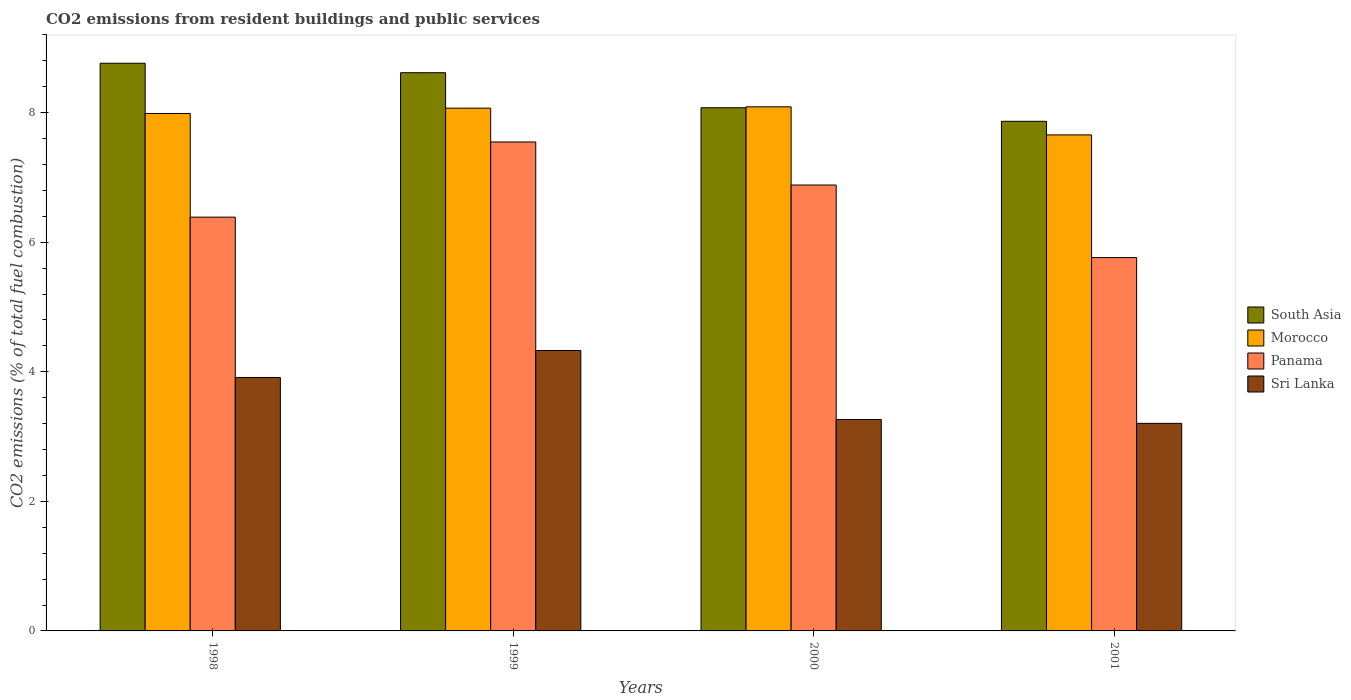How many groups of bars are there?
Make the answer very short. 4. Are the number of bars on each tick of the X-axis equal?
Give a very brief answer. Yes. How many bars are there on the 1st tick from the left?
Ensure brevity in your answer.  4. What is the total CO2 emitted in Sri Lanka in 2000?
Provide a short and direct response. 3.26. Across all years, what is the maximum total CO2 emitted in Morocco?
Provide a succinct answer. 8.09. Across all years, what is the minimum total CO2 emitted in Sri Lanka?
Your response must be concise. 3.2. In which year was the total CO2 emitted in Sri Lanka maximum?
Ensure brevity in your answer.  1999. In which year was the total CO2 emitted in Morocco minimum?
Offer a terse response. 2001. What is the total total CO2 emitted in Morocco in the graph?
Keep it short and to the point. 31.8. What is the difference between the total CO2 emitted in Panama in 1998 and that in 2000?
Provide a succinct answer. -0.5. What is the difference between the total CO2 emitted in Morocco in 2000 and the total CO2 emitted in South Asia in 2001?
Your answer should be very brief. 0.22. What is the average total CO2 emitted in South Asia per year?
Your response must be concise. 8.33. In the year 2001, what is the difference between the total CO2 emitted in Morocco and total CO2 emitted in Panama?
Keep it short and to the point. 1.89. In how many years, is the total CO2 emitted in Morocco greater than 6.8?
Provide a succinct answer. 4. What is the ratio of the total CO2 emitted in Panama in 1999 to that in 2001?
Your answer should be compact. 1.31. Is the difference between the total CO2 emitted in Morocco in 1999 and 2000 greater than the difference between the total CO2 emitted in Panama in 1999 and 2000?
Ensure brevity in your answer.  No. What is the difference between the highest and the second highest total CO2 emitted in Sri Lanka?
Ensure brevity in your answer.  0.42. What is the difference between the highest and the lowest total CO2 emitted in Morocco?
Your answer should be compact. 0.43. Is the sum of the total CO2 emitted in Sri Lanka in 2000 and 2001 greater than the maximum total CO2 emitted in South Asia across all years?
Ensure brevity in your answer.  No. Is it the case that in every year, the sum of the total CO2 emitted in Sri Lanka and total CO2 emitted in Panama is greater than the sum of total CO2 emitted in South Asia and total CO2 emitted in Morocco?
Your response must be concise. No. What does the 3rd bar from the left in 1999 represents?
Keep it short and to the point. Panama. What does the 3rd bar from the right in 1998 represents?
Ensure brevity in your answer.  Morocco. How many bars are there?
Make the answer very short. 16. Are all the bars in the graph horizontal?
Provide a succinct answer. No. How many years are there in the graph?
Provide a short and direct response. 4. What is the title of the graph?
Ensure brevity in your answer.  CO2 emissions from resident buildings and public services. What is the label or title of the X-axis?
Provide a short and direct response. Years. What is the label or title of the Y-axis?
Offer a terse response. CO2 emissions (% of total fuel combustion). What is the CO2 emissions (% of total fuel combustion) of South Asia in 1998?
Give a very brief answer. 8.76. What is the CO2 emissions (% of total fuel combustion) in Morocco in 1998?
Your answer should be very brief. 7.99. What is the CO2 emissions (% of total fuel combustion) in Panama in 1998?
Your response must be concise. 6.39. What is the CO2 emissions (% of total fuel combustion) of Sri Lanka in 1998?
Your response must be concise. 3.91. What is the CO2 emissions (% of total fuel combustion) in South Asia in 1999?
Provide a short and direct response. 8.62. What is the CO2 emissions (% of total fuel combustion) in Morocco in 1999?
Provide a short and direct response. 8.07. What is the CO2 emissions (% of total fuel combustion) in Panama in 1999?
Make the answer very short. 7.55. What is the CO2 emissions (% of total fuel combustion) in Sri Lanka in 1999?
Your response must be concise. 4.33. What is the CO2 emissions (% of total fuel combustion) of South Asia in 2000?
Your answer should be very brief. 8.08. What is the CO2 emissions (% of total fuel combustion) in Morocco in 2000?
Make the answer very short. 8.09. What is the CO2 emissions (% of total fuel combustion) in Panama in 2000?
Your response must be concise. 6.88. What is the CO2 emissions (% of total fuel combustion) of Sri Lanka in 2000?
Ensure brevity in your answer.  3.26. What is the CO2 emissions (% of total fuel combustion) in South Asia in 2001?
Your response must be concise. 7.87. What is the CO2 emissions (% of total fuel combustion) of Morocco in 2001?
Ensure brevity in your answer.  7.66. What is the CO2 emissions (% of total fuel combustion) in Panama in 2001?
Provide a succinct answer. 5.76. What is the CO2 emissions (% of total fuel combustion) of Sri Lanka in 2001?
Give a very brief answer. 3.2. Across all years, what is the maximum CO2 emissions (% of total fuel combustion) in South Asia?
Offer a terse response. 8.76. Across all years, what is the maximum CO2 emissions (% of total fuel combustion) in Morocco?
Your answer should be compact. 8.09. Across all years, what is the maximum CO2 emissions (% of total fuel combustion) in Panama?
Your answer should be very brief. 7.55. Across all years, what is the maximum CO2 emissions (% of total fuel combustion) in Sri Lanka?
Offer a very short reply. 4.33. Across all years, what is the minimum CO2 emissions (% of total fuel combustion) in South Asia?
Make the answer very short. 7.87. Across all years, what is the minimum CO2 emissions (% of total fuel combustion) of Morocco?
Offer a very short reply. 7.66. Across all years, what is the minimum CO2 emissions (% of total fuel combustion) of Panama?
Your response must be concise. 5.76. Across all years, what is the minimum CO2 emissions (% of total fuel combustion) of Sri Lanka?
Give a very brief answer. 3.2. What is the total CO2 emissions (% of total fuel combustion) of South Asia in the graph?
Your answer should be very brief. 33.32. What is the total CO2 emissions (% of total fuel combustion) of Morocco in the graph?
Offer a very short reply. 31.8. What is the total CO2 emissions (% of total fuel combustion) in Panama in the graph?
Provide a short and direct response. 26.58. What is the total CO2 emissions (% of total fuel combustion) of Sri Lanka in the graph?
Your response must be concise. 14.71. What is the difference between the CO2 emissions (% of total fuel combustion) of South Asia in 1998 and that in 1999?
Provide a succinct answer. 0.15. What is the difference between the CO2 emissions (% of total fuel combustion) of Morocco in 1998 and that in 1999?
Your answer should be compact. -0.08. What is the difference between the CO2 emissions (% of total fuel combustion) in Panama in 1998 and that in 1999?
Offer a terse response. -1.16. What is the difference between the CO2 emissions (% of total fuel combustion) in Sri Lanka in 1998 and that in 1999?
Offer a very short reply. -0.42. What is the difference between the CO2 emissions (% of total fuel combustion) in South Asia in 1998 and that in 2000?
Offer a very short reply. 0.69. What is the difference between the CO2 emissions (% of total fuel combustion) in Morocco in 1998 and that in 2000?
Your response must be concise. -0.1. What is the difference between the CO2 emissions (% of total fuel combustion) in Panama in 1998 and that in 2000?
Provide a succinct answer. -0.5. What is the difference between the CO2 emissions (% of total fuel combustion) of Sri Lanka in 1998 and that in 2000?
Offer a terse response. 0.65. What is the difference between the CO2 emissions (% of total fuel combustion) of South Asia in 1998 and that in 2001?
Offer a terse response. 0.9. What is the difference between the CO2 emissions (% of total fuel combustion) of Morocco in 1998 and that in 2001?
Your response must be concise. 0.33. What is the difference between the CO2 emissions (% of total fuel combustion) of Panama in 1998 and that in 2001?
Offer a very short reply. 0.62. What is the difference between the CO2 emissions (% of total fuel combustion) of Sri Lanka in 1998 and that in 2001?
Ensure brevity in your answer.  0.71. What is the difference between the CO2 emissions (% of total fuel combustion) of South Asia in 1999 and that in 2000?
Your answer should be compact. 0.54. What is the difference between the CO2 emissions (% of total fuel combustion) of Morocco in 1999 and that in 2000?
Make the answer very short. -0.02. What is the difference between the CO2 emissions (% of total fuel combustion) of Panama in 1999 and that in 2000?
Ensure brevity in your answer.  0.66. What is the difference between the CO2 emissions (% of total fuel combustion) in Sri Lanka in 1999 and that in 2000?
Provide a succinct answer. 1.07. What is the difference between the CO2 emissions (% of total fuel combustion) of South Asia in 1999 and that in 2001?
Keep it short and to the point. 0.75. What is the difference between the CO2 emissions (% of total fuel combustion) in Morocco in 1999 and that in 2001?
Make the answer very short. 0.41. What is the difference between the CO2 emissions (% of total fuel combustion) of Panama in 1999 and that in 2001?
Offer a very short reply. 1.78. What is the difference between the CO2 emissions (% of total fuel combustion) of Sri Lanka in 1999 and that in 2001?
Your answer should be compact. 1.12. What is the difference between the CO2 emissions (% of total fuel combustion) in South Asia in 2000 and that in 2001?
Keep it short and to the point. 0.21. What is the difference between the CO2 emissions (% of total fuel combustion) in Morocco in 2000 and that in 2001?
Your response must be concise. 0.43. What is the difference between the CO2 emissions (% of total fuel combustion) in Panama in 2000 and that in 2001?
Give a very brief answer. 1.12. What is the difference between the CO2 emissions (% of total fuel combustion) of Sri Lanka in 2000 and that in 2001?
Give a very brief answer. 0.06. What is the difference between the CO2 emissions (% of total fuel combustion) of South Asia in 1998 and the CO2 emissions (% of total fuel combustion) of Morocco in 1999?
Offer a very short reply. 0.69. What is the difference between the CO2 emissions (% of total fuel combustion) of South Asia in 1998 and the CO2 emissions (% of total fuel combustion) of Panama in 1999?
Give a very brief answer. 1.21. What is the difference between the CO2 emissions (% of total fuel combustion) of South Asia in 1998 and the CO2 emissions (% of total fuel combustion) of Sri Lanka in 1999?
Give a very brief answer. 4.43. What is the difference between the CO2 emissions (% of total fuel combustion) in Morocco in 1998 and the CO2 emissions (% of total fuel combustion) in Panama in 1999?
Provide a succinct answer. 0.44. What is the difference between the CO2 emissions (% of total fuel combustion) of Morocco in 1998 and the CO2 emissions (% of total fuel combustion) of Sri Lanka in 1999?
Your response must be concise. 3.66. What is the difference between the CO2 emissions (% of total fuel combustion) of Panama in 1998 and the CO2 emissions (% of total fuel combustion) of Sri Lanka in 1999?
Offer a terse response. 2.06. What is the difference between the CO2 emissions (% of total fuel combustion) in South Asia in 1998 and the CO2 emissions (% of total fuel combustion) in Morocco in 2000?
Your response must be concise. 0.67. What is the difference between the CO2 emissions (% of total fuel combustion) of South Asia in 1998 and the CO2 emissions (% of total fuel combustion) of Panama in 2000?
Make the answer very short. 1.88. What is the difference between the CO2 emissions (% of total fuel combustion) in South Asia in 1998 and the CO2 emissions (% of total fuel combustion) in Sri Lanka in 2000?
Offer a very short reply. 5.5. What is the difference between the CO2 emissions (% of total fuel combustion) in Morocco in 1998 and the CO2 emissions (% of total fuel combustion) in Panama in 2000?
Offer a very short reply. 1.1. What is the difference between the CO2 emissions (% of total fuel combustion) in Morocco in 1998 and the CO2 emissions (% of total fuel combustion) in Sri Lanka in 2000?
Give a very brief answer. 4.72. What is the difference between the CO2 emissions (% of total fuel combustion) of Panama in 1998 and the CO2 emissions (% of total fuel combustion) of Sri Lanka in 2000?
Offer a terse response. 3.12. What is the difference between the CO2 emissions (% of total fuel combustion) in South Asia in 1998 and the CO2 emissions (% of total fuel combustion) in Morocco in 2001?
Make the answer very short. 1.11. What is the difference between the CO2 emissions (% of total fuel combustion) in South Asia in 1998 and the CO2 emissions (% of total fuel combustion) in Panama in 2001?
Provide a short and direct response. 3. What is the difference between the CO2 emissions (% of total fuel combustion) of South Asia in 1998 and the CO2 emissions (% of total fuel combustion) of Sri Lanka in 2001?
Offer a very short reply. 5.56. What is the difference between the CO2 emissions (% of total fuel combustion) in Morocco in 1998 and the CO2 emissions (% of total fuel combustion) in Panama in 2001?
Keep it short and to the point. 2.22. What is the difference between the CO2 emissions (% of total fuel combustion) in Morocco in 1998 and the CO2 emissions (% of total fuel combustion) in Sri Lanka in 2001?
Make the answer very short. 4.78. What is the difference between the CO2 emissions (% of total fuel combustion) in Panama in 1998 and the CO2 emissions (% of total fuel combustion) in Sri Lanka in 2001?
Provide a succinct answer. 3.18. What is the difference between the CO2 emissions (% of total fuel combustion) in South Asia in 1999 and the CO2 emissions (% of total fuel combustion) in Morocco in 2000?
Your answer should be compact. 0.53. What is the difference between the CO2 emissions (% of total fuel combustion) in South Asia in 1999 and the CO2 emissions (% of total fuel combustion) in Panama in 2000?
Provide a short and direct response. 1.73. What is the difference between the CO2 emissions (% of total fuel combustion) of South Asia in 1999 and the CO2 emissions (% of total fuel combustion) of Sri Lanka in 2000?
Give a very brief answer. 5.35. What is the difference between the CO2 emissions (% of total fuel combustion) of Morocco in 1999 and the CO2 emissions (% of total fuel combustion) of Panama in 2000?
Make the answer very short. 1.19. What is the difference between the CO2 emissions (% of total fuel combustion) in Morocco in 1999 and the CO2 emissions (% of total fuel combustion) in Sri Lanka in 2000?
Provide a short and direct response. 4.81. What is the difference between the CO2 emissions (% of total fuel combustion) of Panama in 1999 and the CO2 emissions (% of total fuel combustion) of Sri Lanka in 2000?
Provide a short and direct response. 4.28. What is the difference between the CO2 emissions (% of total fuel combustion) in South Asia in 1999 and the CO2 emissions (% of total fuel combustion) in Morocco in 2001?
Keep it short and to the point. 0.96. What is the difference between the CO2 emissions (% of total fuel combustion) of South Asia in 1999 and the CO2 emissions (% of total fuel combustion) of Panama in 2001?
Provide a short and direct response. 2.85. What is the difference between the CO2 emissions (% of total fuel combustion) of South Asia in 1999 and the CO2 emissions (% of total fuel combustion) of Sri Lanka in 2001?
Keep it short and to the point. 5.41. What is the difference between the CO2 emissions (% of total fuel combustion) in Morocco in 1999 and the CO2 emissions (% of total fuel combustion) in Panama in 2001?
Ensure brevity in your answer.  2.31. What is the difference between the CO2 emissions (% of total fuel combustion) in Morocco in 1999 and the CO2 emissions (% of total fuel combustion) in Sri Lanka in 2001?
Your response must be concise. 4.87. What is the difference between the CO2 emissions (% of total fuel combustion) in Panama in 1999 and the CO2 emissions (% of total fuel combustion) in Sri Lanka in 2001?
Ensure brevity in your answer.  4.34. What is the difference between the CO2 emissions (% of total fuel combustion) in South Asia in 2000 and the CO2 emissions (% of total fuel combustion) in Morocco in 2001?
Your response must be concise. 0.42. What is the difference between the CO2 emissions (% of total fuel combustion) of South Asia in 2000 and the CO2 emissions (% of total fuel combustion) of Panama in 2001?
Keep it short and to the point. 2.31. What is the difference between the CO2 emissions (% of total fuel combustion) in South Asia in 2000 and the CO2 emissions (% of total fuel combustion) in Sri Lanka in 2001?
Offer a very short reply. 4.87. What is the difference between the CO2 emissions (% of total fuel combustion) of Morocco in 2000 and the CO2 emissions (% of total fuel combustion) of Panama in 2001?
Your response must be concise. 2.33. What is the difference between the CO2 emissions (% of total fuel combustion) in Morocco in 2000 and the CO2 emissions (% of total fuel combustion) in Sri Lanka in 2001?
Offer a very short reply. 4.89. What is the difference between the CO2 emissions (% of total fuel combustion) in Panama in 2000 and the CO2 emissions (% of total fuel combustion) in Sri Lanka in 2001?
Your answer should be very brief. 3.68. What is the average CO2 emissions (% of total fuel combustion) in South Asia per year?
Ensure brevity in your answer.  8.33. What is the average CO2 emissions (% of total fuel combustion) of Morocco per year?
Your answer should be compact. 7.95. What is the average CO2 emissions (% of total fuel combustion) in Panama per year?
Your response must be concise. 6.64. What is the average CO2 emissions (% of total fuel combustion) of Sri Lanka per year?
Your response must be concise. 3.68. In the year 1998, what is the difference between the CO2 emissions (% of total fuel combustion) in South Asia and CO2 emissions (% of total fuel combustion) in Morocco?
Your answer should be very brief. 0.78. In the year 1998, what is the difference between the CO2 emissions (% of total fuel combustion) of South Asia and CO2 emissions (% of total fuel combustion) of Panama?
Make the answer very short. 2.38. In the year 1998, what is the difference between the CO2 emissions (% of total fuel combustion) in South Asia and CO2 emissions (% of total fuel combustion) in Sri Lanka?
Your answer should be compact. 4.85. In the year 1998, what is the difference between the CO2 emissions (% of total fuel combustion) of Morocco and CO2 emissions (% of total fuel combustion) of Sri Lanka?
Ensure brevity in your answer.  4.07. In the year 1998, what is the difference between the CO2 emissions (% of total fuel combustion) in Panama and CO2 emissions (% of total fuel combustion) in Sri Lanka?
Make the answer very short. 2.47. In the year 1999, what is the difference between the CO2 emissions (% of total fuel combustion) in South Asia and CO2 emissions (% of total fuel combustion) in Morocco?
Provide a short and direct response. 0.55. In the year 1999, what is the difference between the CO2 emissions (% of total fuel combustion) in South Asia and CO2 emissions (% of total fuel combustion) in Panama?
Provide a short and direct response. 1.07. In the year 1999, what is the difference between the CO2 emissions (% of total fuel combustion) in South Asia and CO2 emissions (% of total fuel combustion) in Sri Lanka?
Offer a terse response. 4.29. In the year 1999, what is the difference between the CO2 emissions (% of total fuel combustion) of Morocco and CO2 emissions (% of total fuel combustion) of Panama?
Keep it short and to the point. 0.52. In the year 1999, what is the difference between the CO2 emissions (% of total fuel combustion) in Morocco and CO2 emissions (% of total fuel combustion) in Sri Lanka?
Provide a short and direct response. 3.74. In the year 1999, what is the difference between the CO2 emissions (% of total fuel combustion) in Panama and CO2 emissions (% of total fuel combustion) in Sri Lanka?
Your answer should be compact. 3.22. In the year 2000, what is the difference between the CO2 emissions (% of total fuel combustion) in South Asia and CO2 emissions (% of total fuel combustion) in Morocco?
Provide a short and direct response. -0.01. In the year 2000, what is the difference between the CO2 emissions (% of total fuel combustion) of South Asia and CO2 emissions (% of total fuel combustion) of Panama?
Keep it short and to the point. 1.19. In the year 2000, what is the difference between the CO2 emissions (% of total fuel combustion) in South Asia and CO2 emissions (% of total fuel combustion) in Sri Lanka?
Your answer should be very brief. 4.81. In the year 2000, what is the difference between the CO2 emissions (% of total fuel combustion) of Morocco and CO2 emissions (% of total fuel combustion) of Panama?
Make the answer very short. 1.21. In the year 2000, what is the difference between the CO2 emissions (% of total fuel combustion) in Morocco and CO2 emissions (% of total fuel combustion) in Sri Lanka?
Give a very brief answer. 4.83. In the year 2000, what is the difference between the CO2 emissions (% of total fuel combustion) in Panama and CO2 emissions (% of total fuel combustion) in Sri Lanka?
Give a very brief answer. 3.62. In the year 2001, what is the difference between the CO2 emissions (% of total fuel combustion) in South Asia and CO2 emissions (% of total fuel combustion) in Morocco?
Provide a succinct answer. 0.21. In the year 2001, what is the difference between the CO2 emissions (% of total fuel combustion) in South Asia and CO2 emissions (% of total fuel combustion) in Panama?
Keep it short and to the point. 2.1. In the year 2001, what is the difference between the CO2 emissions (% of total fuel combustion) of South Asia and CO2 emissions (% of total fuel combustion) of Sri Lanka?
Keep it short and to the point. 4.66. In the year 2001, what is the difference between the CO2 emissions (% of total fuel combustion) in Morocco and CO2 emissions (% of total fuel combustion) in Panama?
Provide a short and direct response. 1.89. In the year 2001, what is the difference between the CO2 emissions (% of total fuel combustion) in Morocco and CO2 emissions (% of total fuel combustion) in Sri Lanka?
Give a very brief answer. 4.45. In the year 2001, what is the difference between the CO2 emissions (% of total fuel combustion) of Panama and CO2 emissions (% of total fuel combustion) of Sri Lanka?
Make the answer very short. 2.56. What is the ratio of the CO2 emissions (% of total fuel combustion) in South Asia in 1998 to that in 1999?
Provide a short and direct response. 1.02. What is the ratio of the CO2 emissions (% of total fuel combustion) in Panama in 1998 to that in 1999?
Ensure brevity in your answer.  0.85. What is the ratio of the CO2 emissions (% of total fuel combustion) of Sri Lanka in 1998 to that in 1999?
Provide a succinct answer. 0.9. What is the ratio of the CO2 emissions (% of total fuel combustion) of South Asia in 1998 to that in 2000?
Keep it short and to the point. 1.08. What is the ratio of the CO2 emissions (% of total fuel combustion) in Morocco in 1998 to that in 2000?
Ensure brevity in your answer.  0.99. What is the ratio of the CO2 emissions (% of total fuel combustion) of Panama in 1998 to that in 2000?
Your response must be concise. 0.93. What is the ratio of the CO2 emissions (% of total fuel combustion) of Sri Lanka in 1998 to that in 2000?
Give a very brief answer. 1.2. What is the ratio of the CO2 emissions (% of total fuel combustion) of South Asia in 1998 to that in 2001?
Your answer should be compact. 1.11. What is the ratio of the CO2 emissions (% of total fuel combustion) of Morocco in 1998 to that in 2001?
Provide a succinct answer. 1.04. What is the ratio of the CO2 emissions (% of total fuel combustion) of Panama in 1998 to that in 2001?
Your answer should be compact. 1.11. What is the ratio of the CO2 emissions (% of total fuel combustion) of Sri Lanka in 1998 to that in 2001?
Provide a short and direct response. 1.22. What is the ratio of the CO2 emissions (% of total fuel combustion) in South Asia in 1999 to that in 2000?
Provide a succinct answer. 1.07. What is the ratio of the CO2 emissions (% of total fuel combustion) in Panama in 1999 to that in 2000?
Your response must be concise. 1.1. What is the ratio of the CO2 emissions (% of total fuel combustion) in Sri Lanka in 1999 to that in 2000?
Your answer should be very brief. 1.33. What is the ratio of the CO2 emissions (% of total fuel combustion) in South Asia in 1999 to that in 2001?
Keep it short and to the point. 1.1. What is the ratio of the CO2 emissions (% of total fuel combustion) of Morocco in 1999 to that in 2001?
Offer a terse response. 1.05. What is the ratio of the CO2 emissions (% of total fuel combustion) of Panama in 1999 to that in 2001?
Your answer should be very brief. 1.31. What is the ratio of the CO2 emissions (% of total fuel combustion) in Sri Lanka in 1999 to that in 2001?
Provide a short and direct response. 1.35. What is the ratio of the CO2 emissions (% of total fuel combustion) in South Asia in 2000 to that in 2001?
Make the answer very short. 1.03. What is the ratio of the CO2 emissions (% of total fuel combustion) in Morocco in 2000 to that in 2001?
Provide a succinct answer. 1.06. What is the ratio of the CO2 emissions (% of total fuel combustion) in Panama in 2000 to that in 2001?
Your answer should be very brief. 1.19. What is the ratio of the CO2 emissions (% of total fuel combustion) in Sri Lanka in 2000 to that in 2001?
Offer a very short reply. 1.02. What is the difference between the highest and the second highest CO2 emissions (% of total fuel combustion) in South Asia?
Provide a succinct answer. 0.15. What is the difference between the highest and the second highest CO2 emissions (% of total fuel combustion) in Morocco?
Offer a terse response. 0.02. What is the difference between the highest and the second highest CO2 emissions (% of total fuel combustion) in Panama?
Offer a terse response. 0.66. What is the difference between the highest and the second highest CO2 emissions (% of total fuel combustion) of Sri Lanka?
Offer a very short reply. 0.42. What is the difference between the highest and the lowest CO2 emissions (% of total fuel combustion) of South Asia?
Make the answer very short. 0.9. What is the difference between the highest and the lowest CO2 emissions (% of total fuel combustion) of Morocco?
Keep it short and to the point. 0.43. What is the difference between the highest and the lowest CO2 emissions (% of total fuel combustion) of Panama?
Your answer should be very brief. 1.78. What is the difference between the highest and the lowest CO2 emissions (% of total fuel combustion) in Sri Lanka?
Offer a terse response. 1.12. 